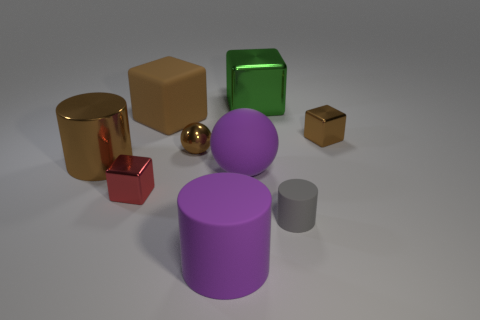Subtract 1 cubes. How many cubes are left? 3 Subtract all blocks. How many objects are left? 5 Subtract 1 brown cylinders. How many objects are left? 8 Subtract all small brown balls. Subtract all green things. How many objects are left? 7 Add 2 matte objects. How many matte objects are left? 6 Add 5 tiny metallic cubes. How many tiny metallic cubes exist? 7 